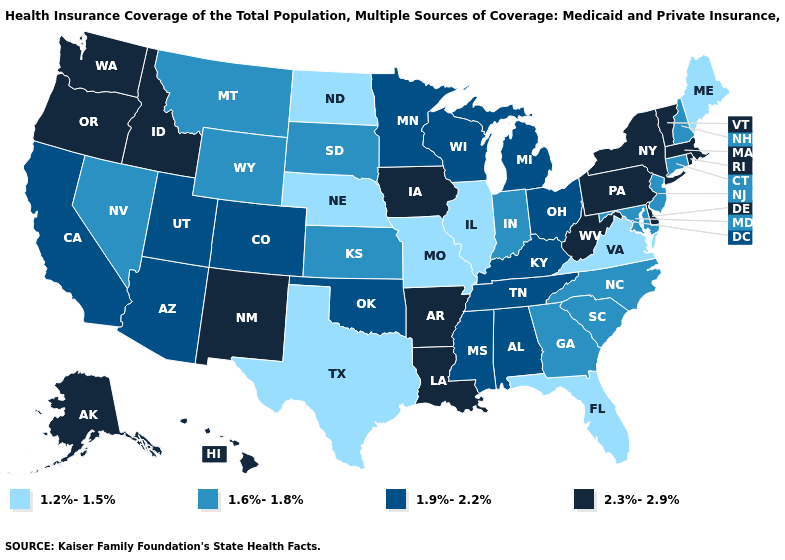Name the states that have a value in the range 2.3%-2.9%?
Write a very short answer. Alaska, Arkansas, Delaware, Hawaii, Idaho, Iowa, Louisiana, Massachusetts, New Mexico, New York, Oregon, Pennsylvania, Rhode Island, Vermont, Washington, West Virginia. Does Oregon have the same value as Ohio?
Answer briefly. No. Does Nevada have the same value as Florida?
Short answer required. No. Among the states that border Idaho , which have the highest value?
Short answer required. Oregon, Washington. Name the states that have a value in the range 1.2%-1.5%?
Give a very brief answer. Florida, Illinois, Maine, Missouri, Nebraska, North Dakota, Texas, Virginia. Name the states that have a value in the range 1.9%-2.2%?
Short answer required. Alabama, Arizona, California, Colorado, Kentucky, Michigan, Minnesota, Mississippi, Ohio, Oklahoma, Tennessee, Utah, Wisconsin. What is the value of Rhode Island?
Short answer required. 2.3%-2.9%. Does the map have missing data?
Short answer required. No. Does Connecticut have the highest value in the Northeast?
Be succinct. No. What is the value of Montana?
Quick response, please. 1.6%-1.8%. What is the value of Texas?
Be succinct. 1.2%-1.5%. Does the first symbol in the legend represent the smallest category?
Concise answer only. Yes. What is the lowest value in the USA?
Answer briefly. 1.2%-1.5%. Does the first symbol in the legend represent the smallest category?
Write a very short answer. Yes. What is the highest value in the USA?
Be succinct. 2.3%-2.9%. 